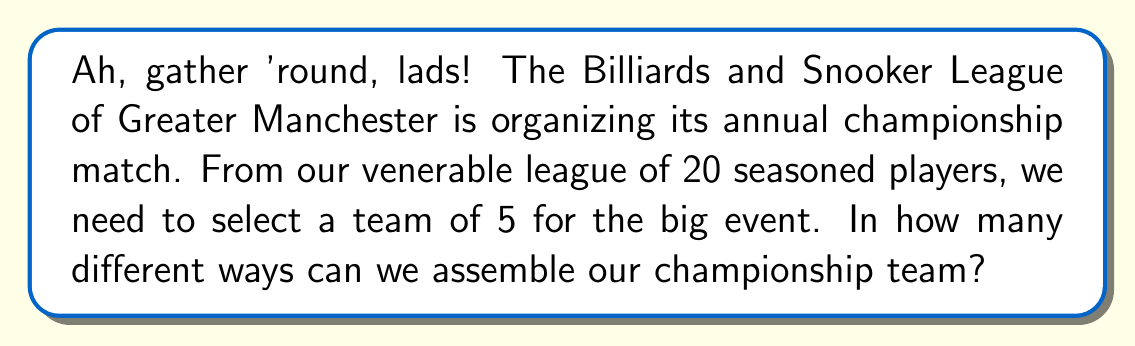Teach me how to tackle this problem. Right then, let's break this down step by step:

1) We're selecting 5 players from a total of 20. The order of selection doesn't matter - it's the same team whether we pick Old Tom first or last.

2) This scenario calls for a combination calculation. We use the combination formula:

   $${n \choose r} = \frac{n!}{r!(n-r)!}$$

   Where $n$ is the total number of players, and $r$ is the number we're selecting.

3) In this case, $n = 20$ and $r = 5$. Let's plug these into our formula:

   $${20 \choose 5} = \frac{20!}{5!(20-5)!} = \frac{20!}{5!15!}$$

4) Now, let's calculate this step-by-step:
   
   $$\frac{20 \cdot 19 \cdot 18 \cdot 17 \cdot 16 \cdot 15!}{(5 \cdot 4 \cdot 3 \cdot 2 \cdot 1) \cdot 15!}$$

5) The 15! cancels out in the numerator and denominator:

   $$\frac{20 \cdot 19 \cdot 18 \cdot 17 \cdot 16}{5 \cdot 4 \cdot 3 \cdot 2 \cdot 1}$$

6) Multiply the top and bottom:

   $$\frac{1,860,480}{120} = 15,504$$

And there you have it! 15,504 different ways to select our championship team. Quite a few options to mull over at the pub, eh?
Answer: 15,504 